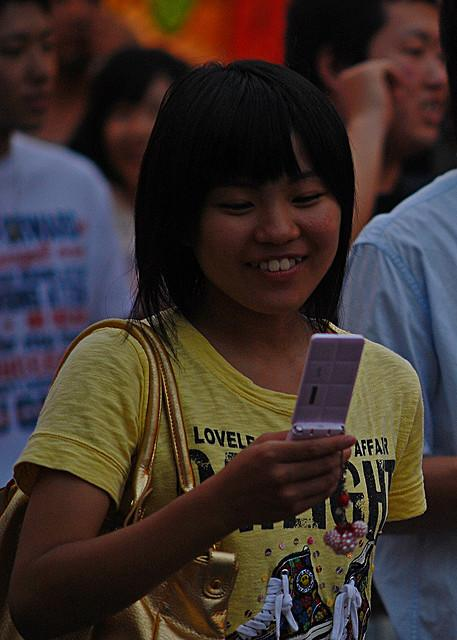What is there a picture of on the yellow shirt? shoes 